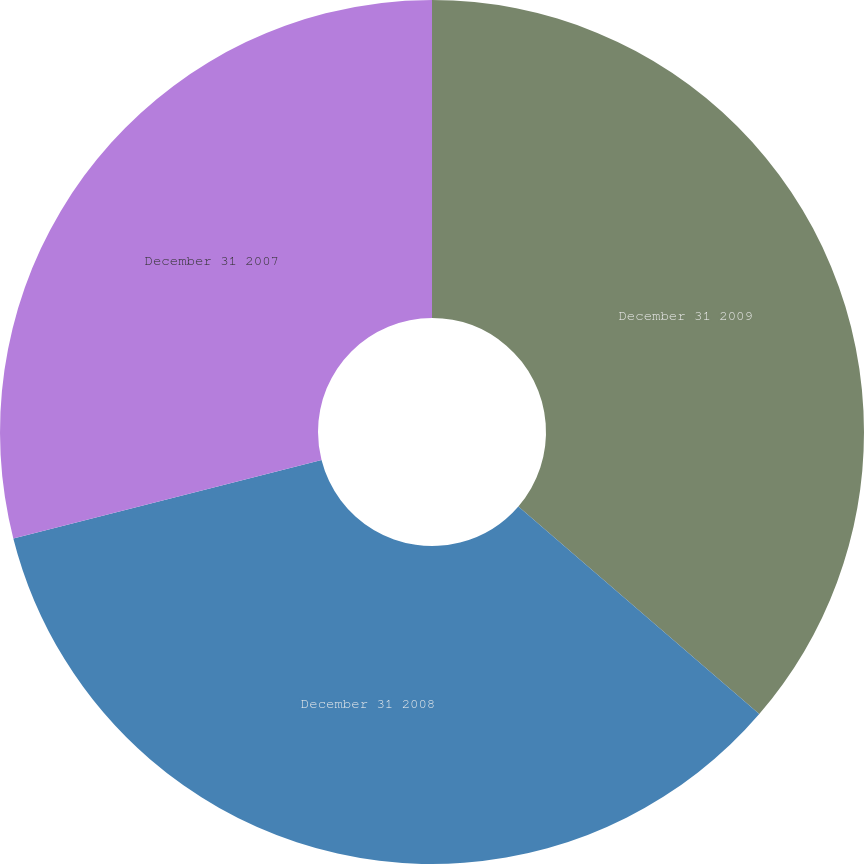<chart> <loc_0><loc_0><loc_500><loc_500><pie_chart><fcel>December 31 2009<fcel>December 31 2008<fcel>December 31 2007<nl><fcel>36.32%<fcel>34.72%<fcel>28.96%<nl></chart> 